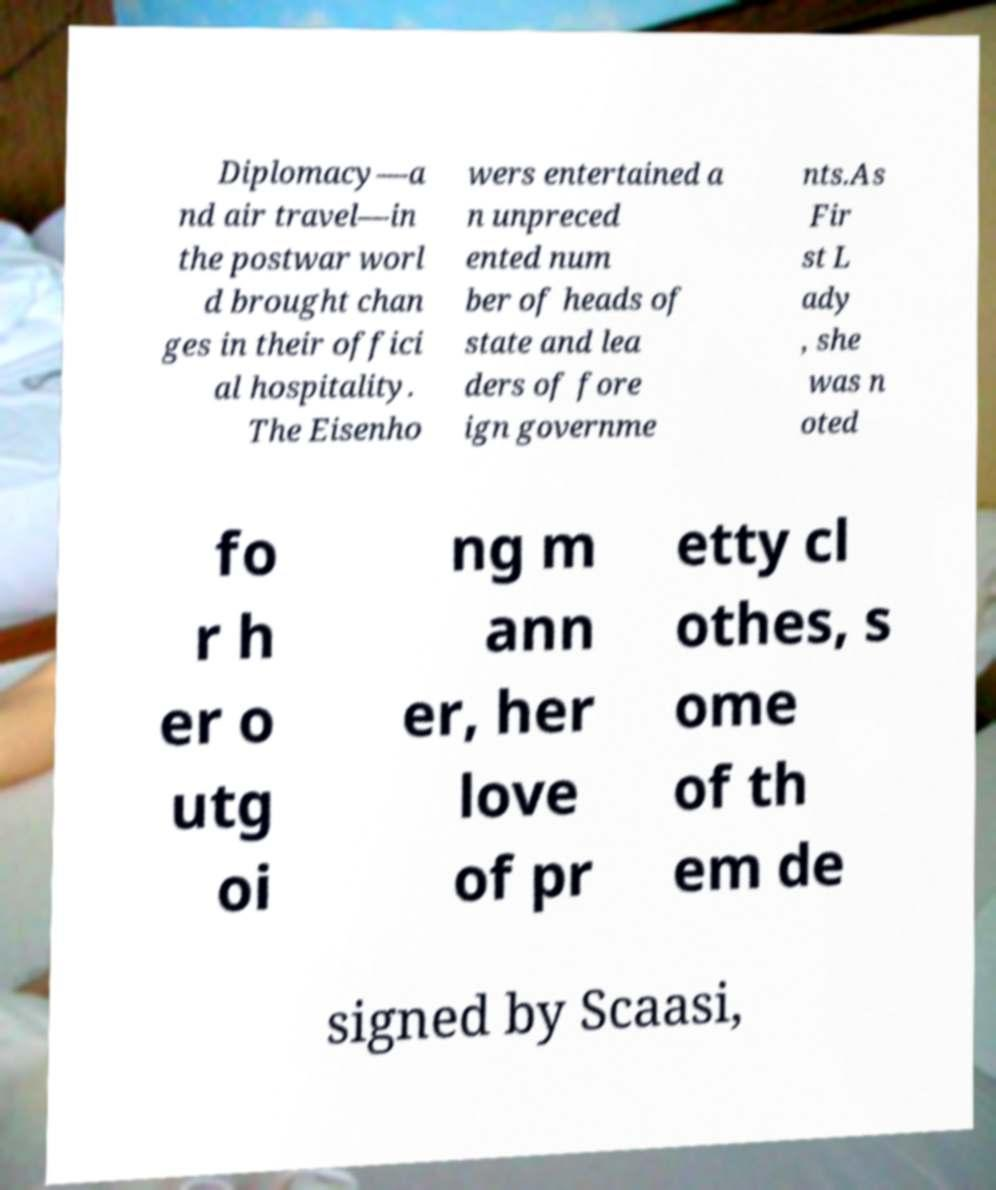Please identify and transcribe the text found in this image. Diplomacy—a nd air travel—in the postwar worl d brought chan ges in their offici al hospitality. The Eisenho wers entertained a n unpreced ented num ber of heads of state and lea ders of fore ign governme nts.As Fir st L ady , she was n oted fo r h er o utg oi ng m ann er, her love of pr etty cl othes, s ome of th em de signed by Scaasi, 